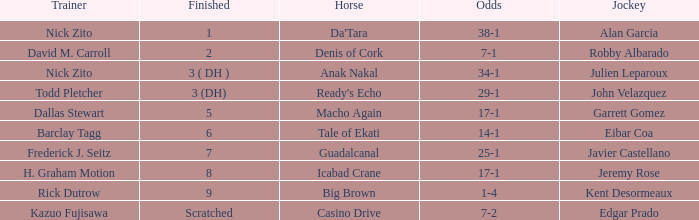Which Horse finished in 8? Icabad Crane. 